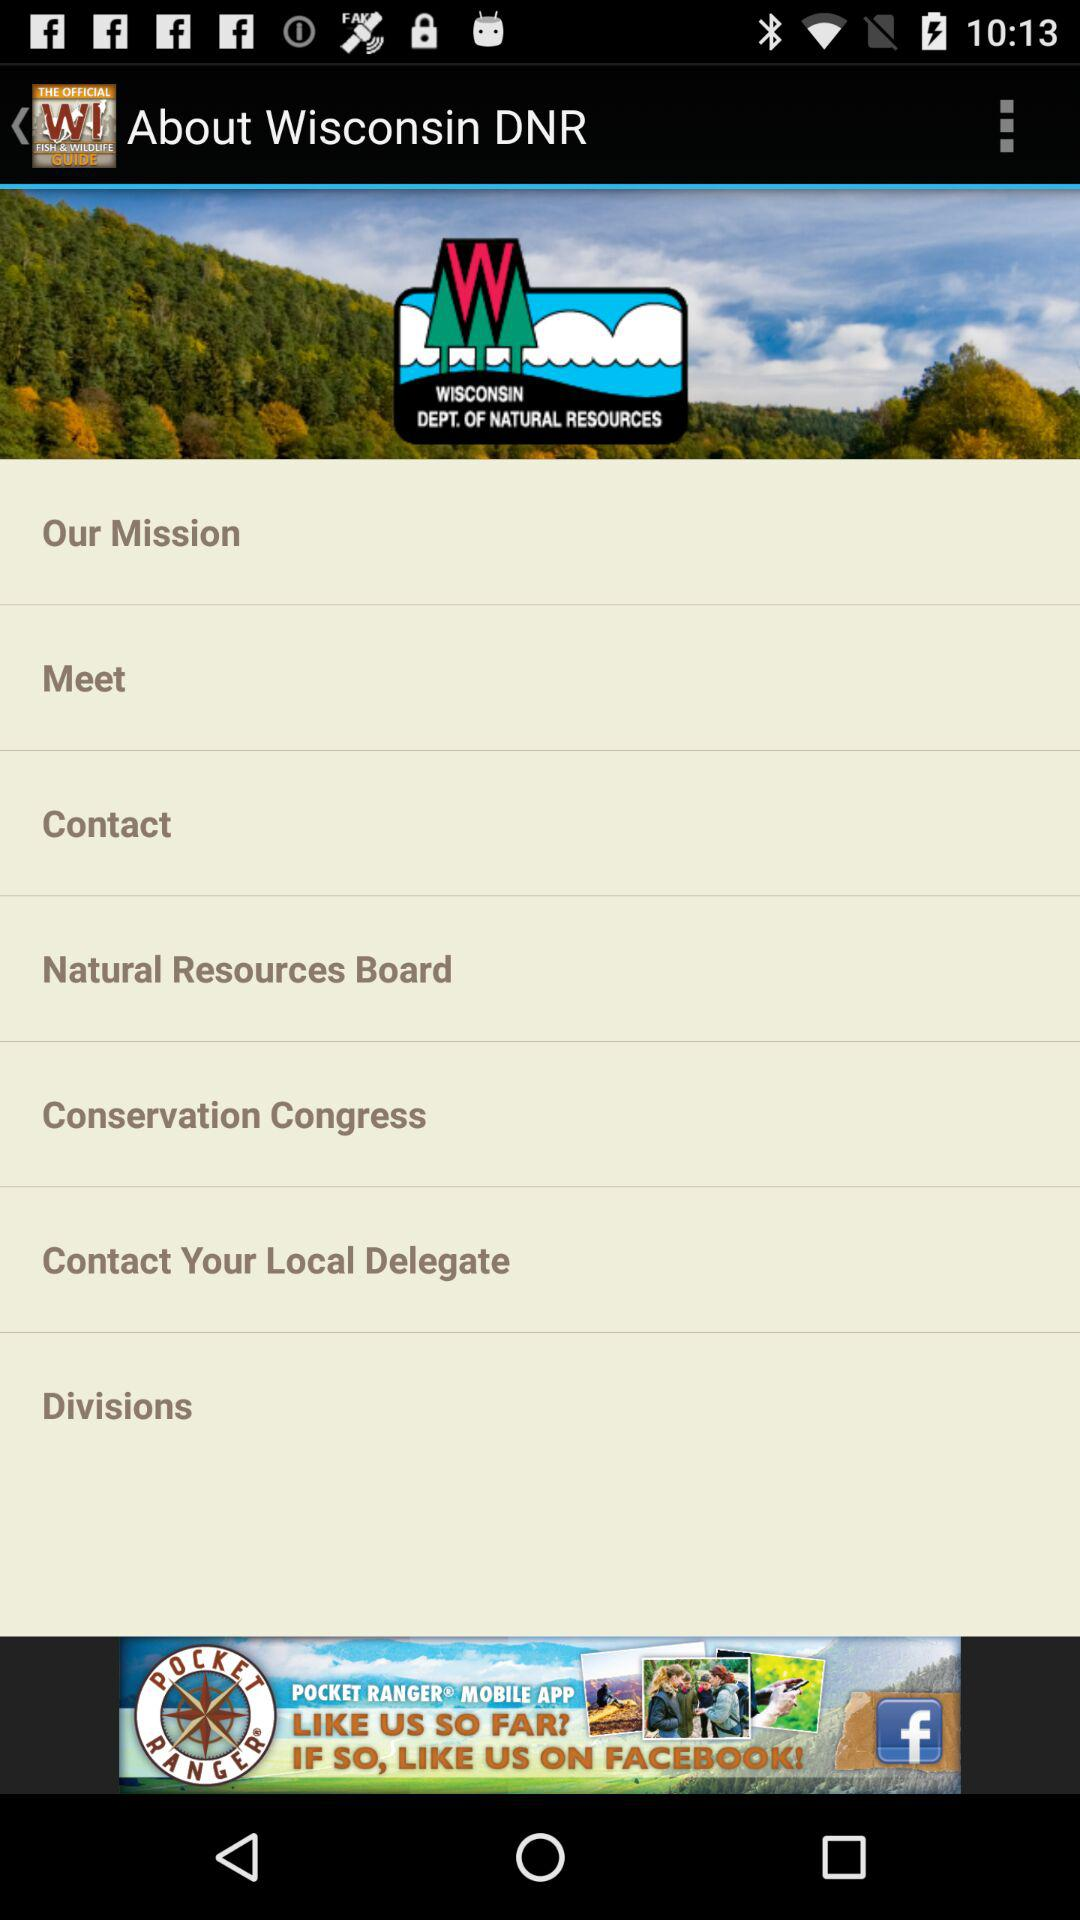What is the application name? The application name is "Wisconsin Fish & Wildlife Guide". 